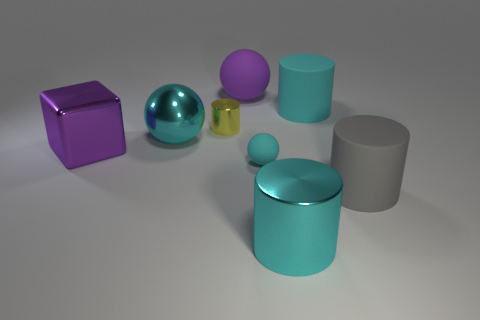Subtract all large cyan shiny cylinders. How many cylinders are left? 3 Add 1 tiny yellow metallic things. How many objects exist? 9 Subtract all purple cylinders. Subtract all blue spheres. How many cylinders are left? 4 Subtract all blocks. How many objects are left? 7 Add 8 large metallic balls. How many large metallic balls exist? 9 Subtract 1 cyan cylinders. How many objects are left? 7 Subtract all big cyan cylinders. Subtract all tiny yellow objects. How many objects are left? 5 Add 2 tiny yellow metallic things. How many tiny yellow metallic things are left? 3 